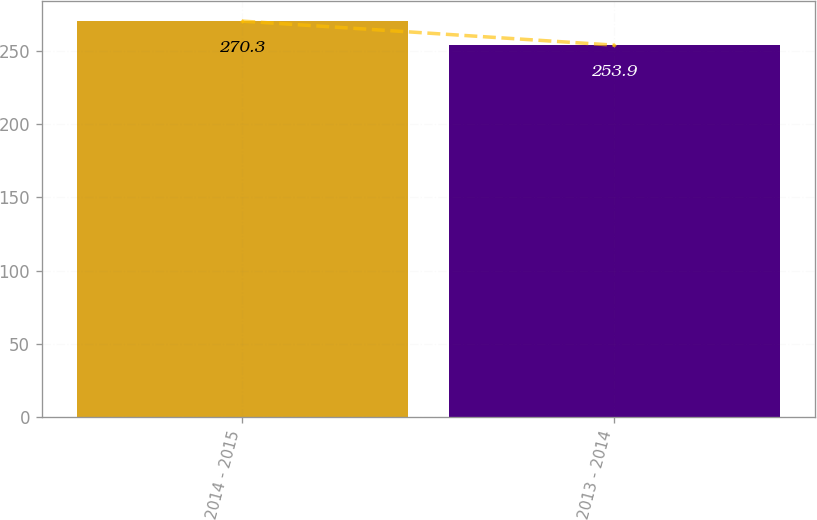Convert chart to OTSL. <chart><loc_0><loc_0><loc_500><loc_500><bar_chart><fcel>2014 - 2015<fcel>2013 - 2014<nl><fcel>270.3<fcel>253.9<nl></chart> 